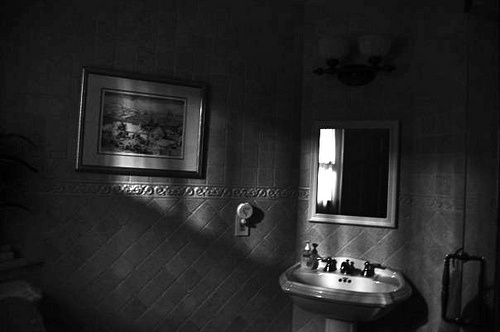Describe the objects in this image and their specific colors. I can see sink in black, gray, lightgray, and darkgray tones and bottle in black, gray, darkgray, and white tones in this image. 